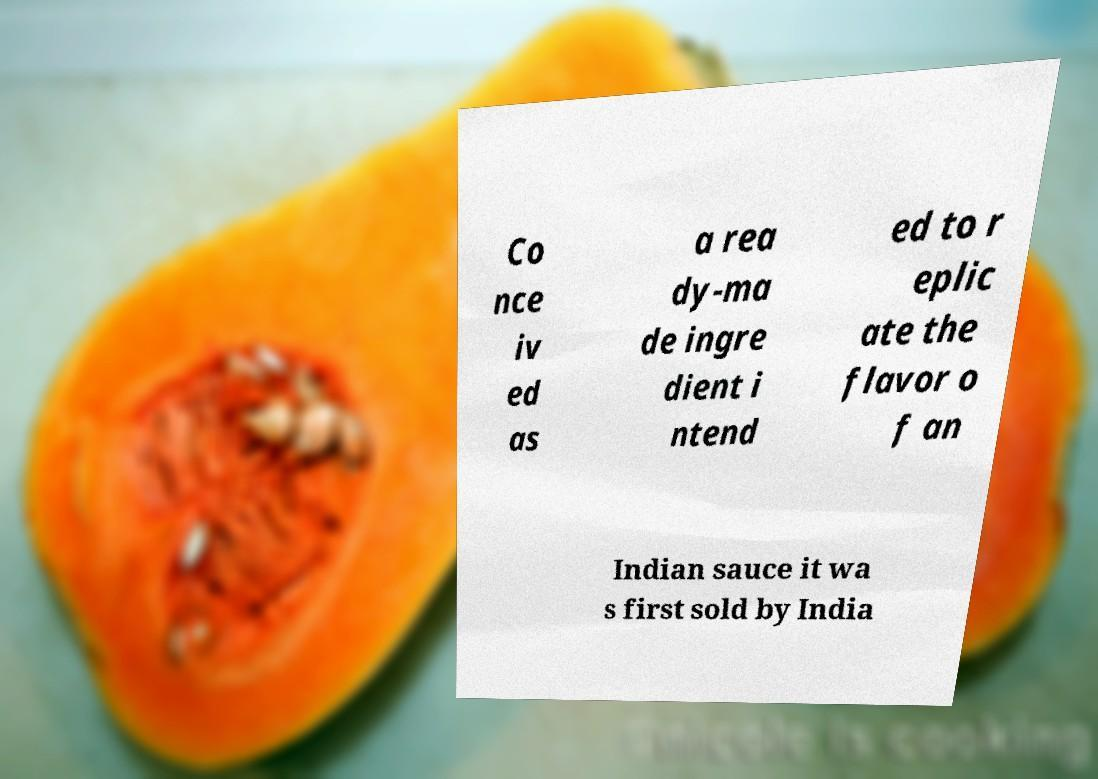Could you extract and type out the text from this image? Co nce iv ed as a rea dy-ma de ingre dient i ntend ed to r eplic ate the flavor o f an Indian sauce it wa s first sold by India 